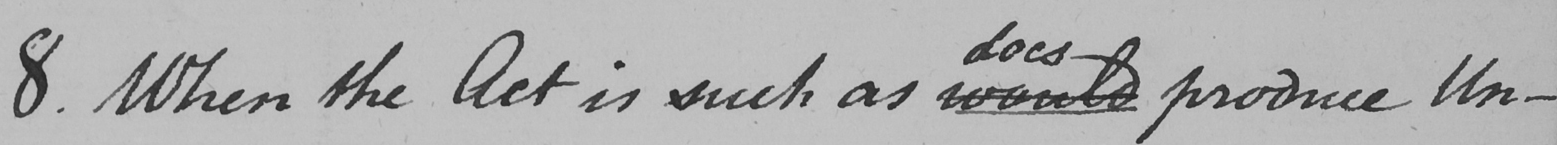What is written in this line of handwriting? 8 . When the Act is such as would produce Un- 